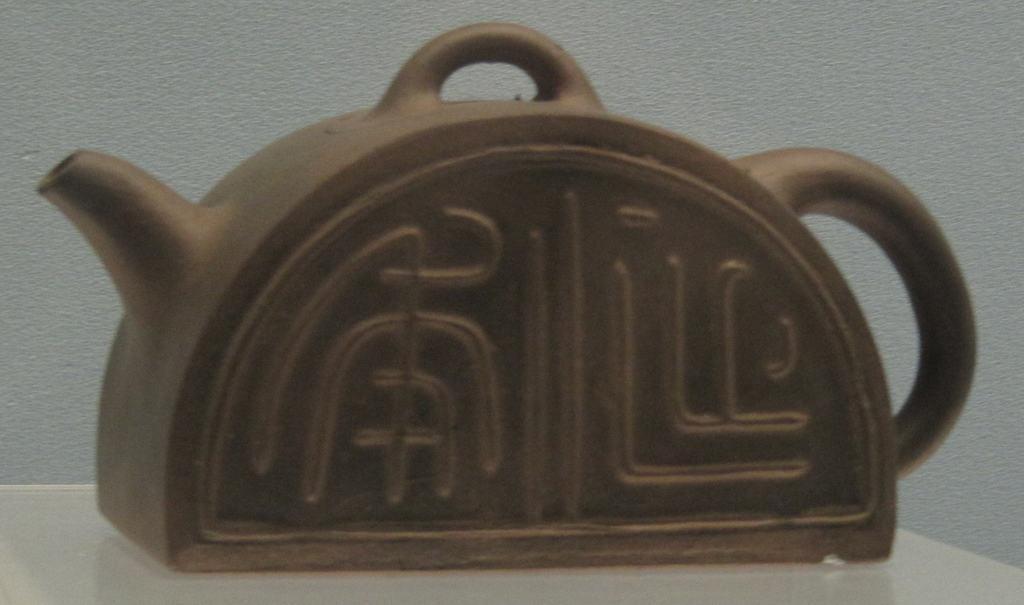Describe this image in one or two sentences. In this image we can see kettle placed on the table. In the background there is wall. 